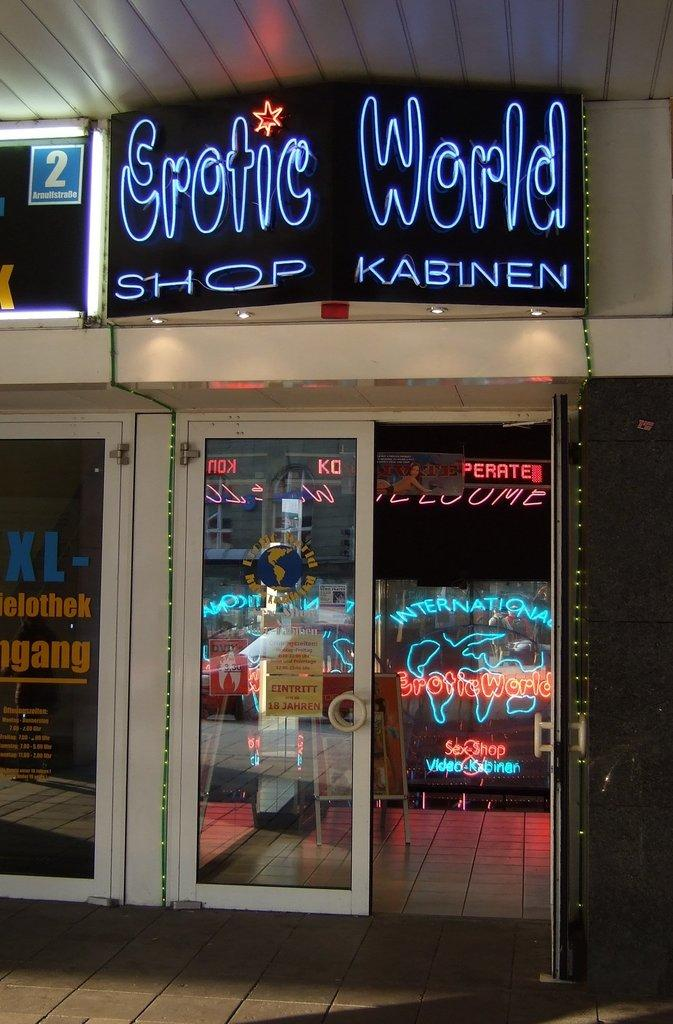What type of establishment is depicted in the image? The image is a front view of a shop. What color are the walls and roof of the shop? The walls and roof of the shop are white. What color is the banner of the shop? The banner of the shop is black. Can you tell me how many cows are standing in front of the shop in the image? There are no cows present in the image; it depicts a shop with a white exterior and a black banner. 